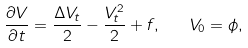Convert formula to latex. <formula><loc_0><loc_0><loc_500><loc_500>\frac { \partial V } { \partial t } = \frac { \Delta V _ { t } } { 2 } - \frac { V _ { t } ^ { 2 } } { 2 } + f , \quad V _ { 0 } = \phi ,</formula> 